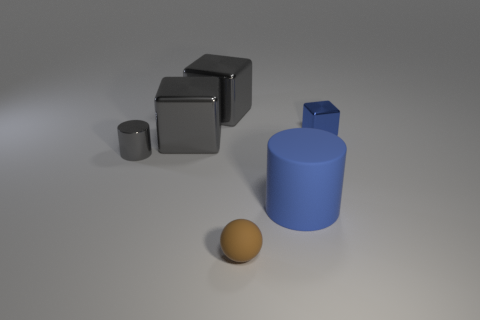There is a cylinder to the right of the tiny gray cylinder left of the cylinder that is in front of the tiny gray shiny object; what color is it?
Provide a succinct answer. Blue. There is a metallic cube on the right side of the brown object; does it have the same color as the big cylinder?
Offer a very short reply. Yes. How many other objects are the same color as the shiny cylinder?
Make the answer very short. 2. What number of objects are gray blocks or metal cylinders?
Ensure brevity in your answer.  3. How many things are large metal things or gray cubes in front of the small blue metallic object?
Your answer should be compact. 2. Is the material of the gray cylinder the same as the brown ball?
Your answer should be very brief. No. How many other things are there of the same material as the tiny brown object?
Provide a succinct answer. 1. Are there more metal cubes than blue cylinders?
Your response must be concise. Yes. There is a small gray object that is behind the large matte thing; does it have the same shape as the brown matte thing?
Your answer should be very brief. No. Is the number of big blue shiny objects less than the number of brown rubber objects?
Offer a terse response. Yes. 